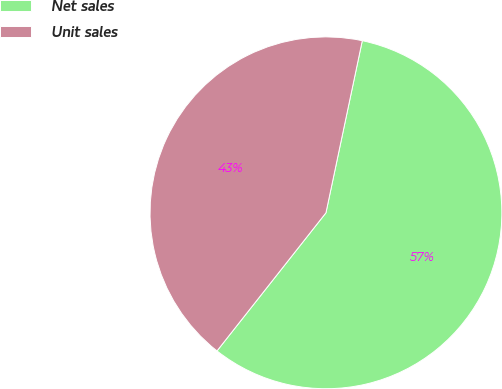Convert chart to OTSL. <chart><loc_0><loc_0><loc_500><loc_500><pie_chart><fcel>Net sales<fcel>Unit sales<nl><fcel>57.32%<fcel>42.68%<nl></chart> 